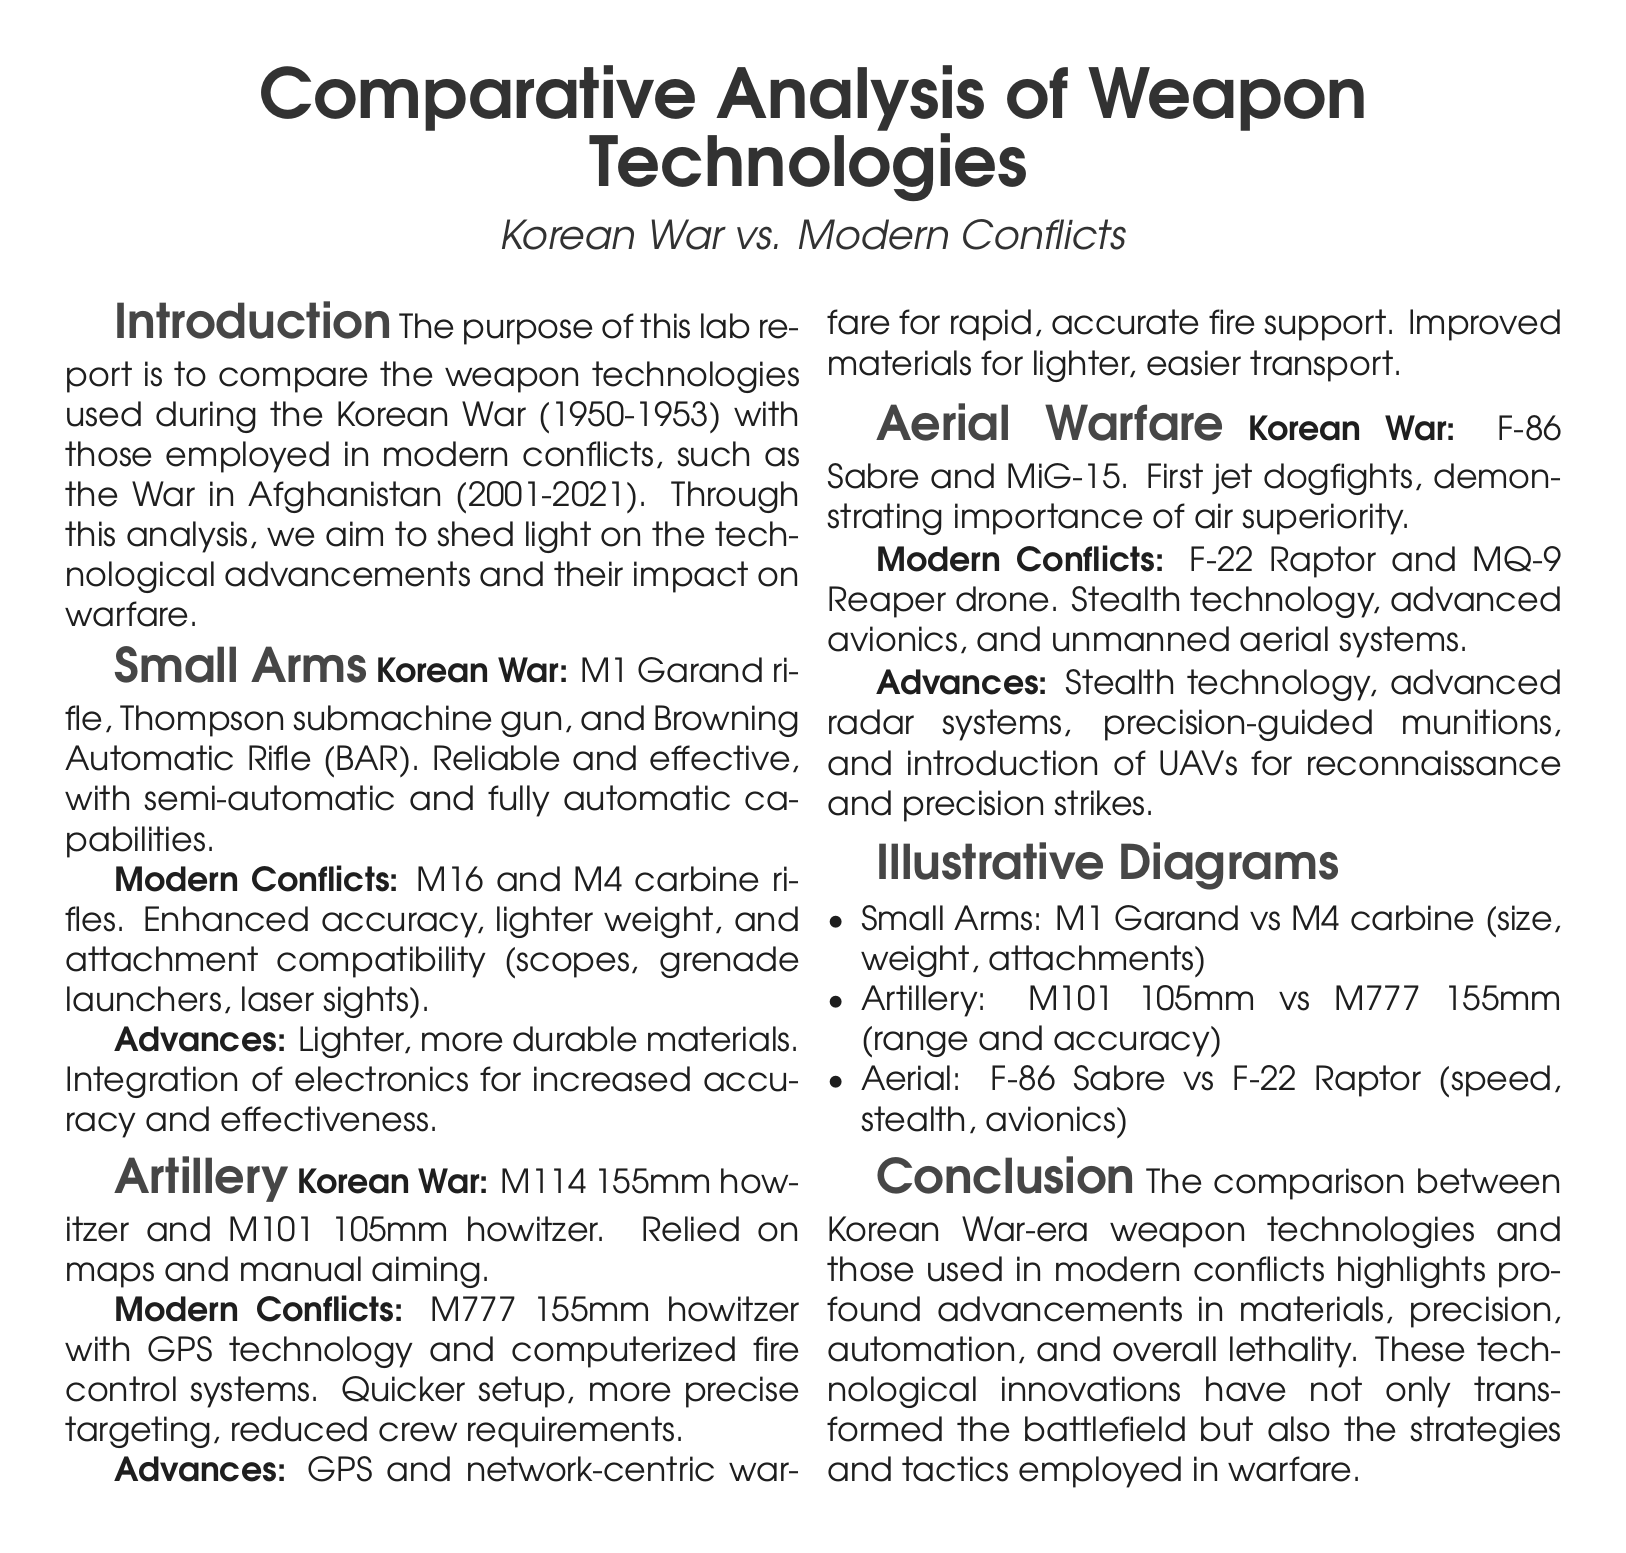What small arms were used in the Korean War? The small arms listed in the document for the Korean War include the M1 Garand rifle, Thompson submachine gun, and Browning Automatic Rifle (BAR).
Answer: M1 Garand rifle, Thompson submachine gun, and Browning Automatic Rifle (BAR) What is an advanced feature of modern artillery? The document states that modern artillery, such as the M777 155mm howitzer, uses GPS technology and computerized fire control systems for improved accuracy.
Answer: GPS technology What type of aircraft is the F-86 Sabre? The document identifies the F-86 Sabre as a fighter aircraft used during the Korean War, notable for being part of the first jet dogfights.
Answer: Fighter aircraft What significant advancement is noted for small arms in modern conflicts? Enhanced accuracy and attachment compatibility for the M16 and M4 carbine rifles represents a major advancement in small arms for modern conflicts.
Answer: Enhanced accuracy, attachment compatibility How many conflicts are specifically compared in the document? The lab report compares the weapon technologies used during the Korean War and those in modern conflicts like the War in Afghanistan, indicating two conflicts in total.
Answer: Two conflicts What is a key technological advancement in aerial warfare? According to the document, stealth technology is identified as a key advancement in aerial warfare, particularly for aircraft such as the F-22 Raptor.
Answer: Stealth technology What year range does the Korean War cover? The document specifies the Korean War took place between the years 1950 and 1953.
Answer: 1950-1953 